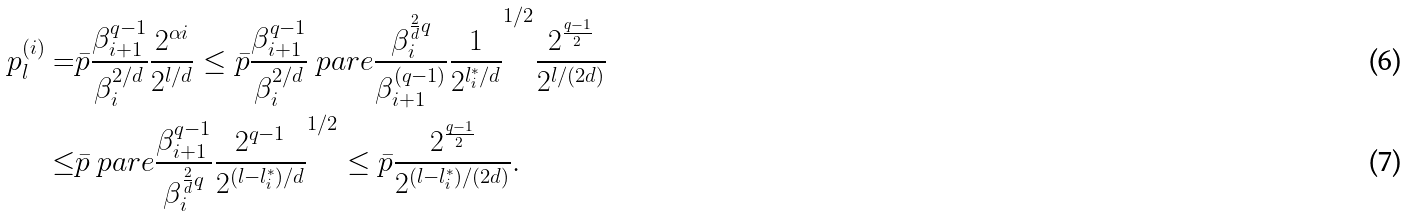Convert formula to latex. <formula><loc_0><loc_0><loc_500><loc_500>p _ { l } ^ { ( i ) } = & \bar { p } \frac { \beta _ { i + 1 } ^ { q - 1 } } { \beta _ { i } ^ { 2 / d } } \frac { 2 ^ { \alpha i } } { 2 ^ { l / d } } \leq \bar { p } \frac { \beta _ { i + 1 } ^ { q - 1 } } { \beta _ { i } ^ { 2 / d } } \ p a r e { \frac { \beta _ { i } ^ { \frac { 2 } { d } q } } { \beta _ { i + 1 } ^ { ( q - 1 ) } } \frac { 1 } { 2 ^ { l _ { i } ^ { * } / d } } } ^ { 1 / 2 } \frac { 2 ^ { \frac { q - 1 } { 2 } } } { 2 ^ { l / ( 2 d ) } } \\ \leq & \bar { p } \ p a r e { \frac { \beta _ { i + 1 } ^ { q - 1 } } { \beta _ { i } ^ { \frac { 2 } { d } q } } \frac { 2 ^ { q - 1 } } { 2 ^ { ( l - l _ { i } ^ { * } ) / d } } } ^ { 1 / 2 } \leq \bar { p } \frac { 2 ^ { \frac { q - 1 } { 2 } } } { 2 ^ { ( l - l _ { i } ^ { * } ) / ( 2 d ) } } .</formula> 